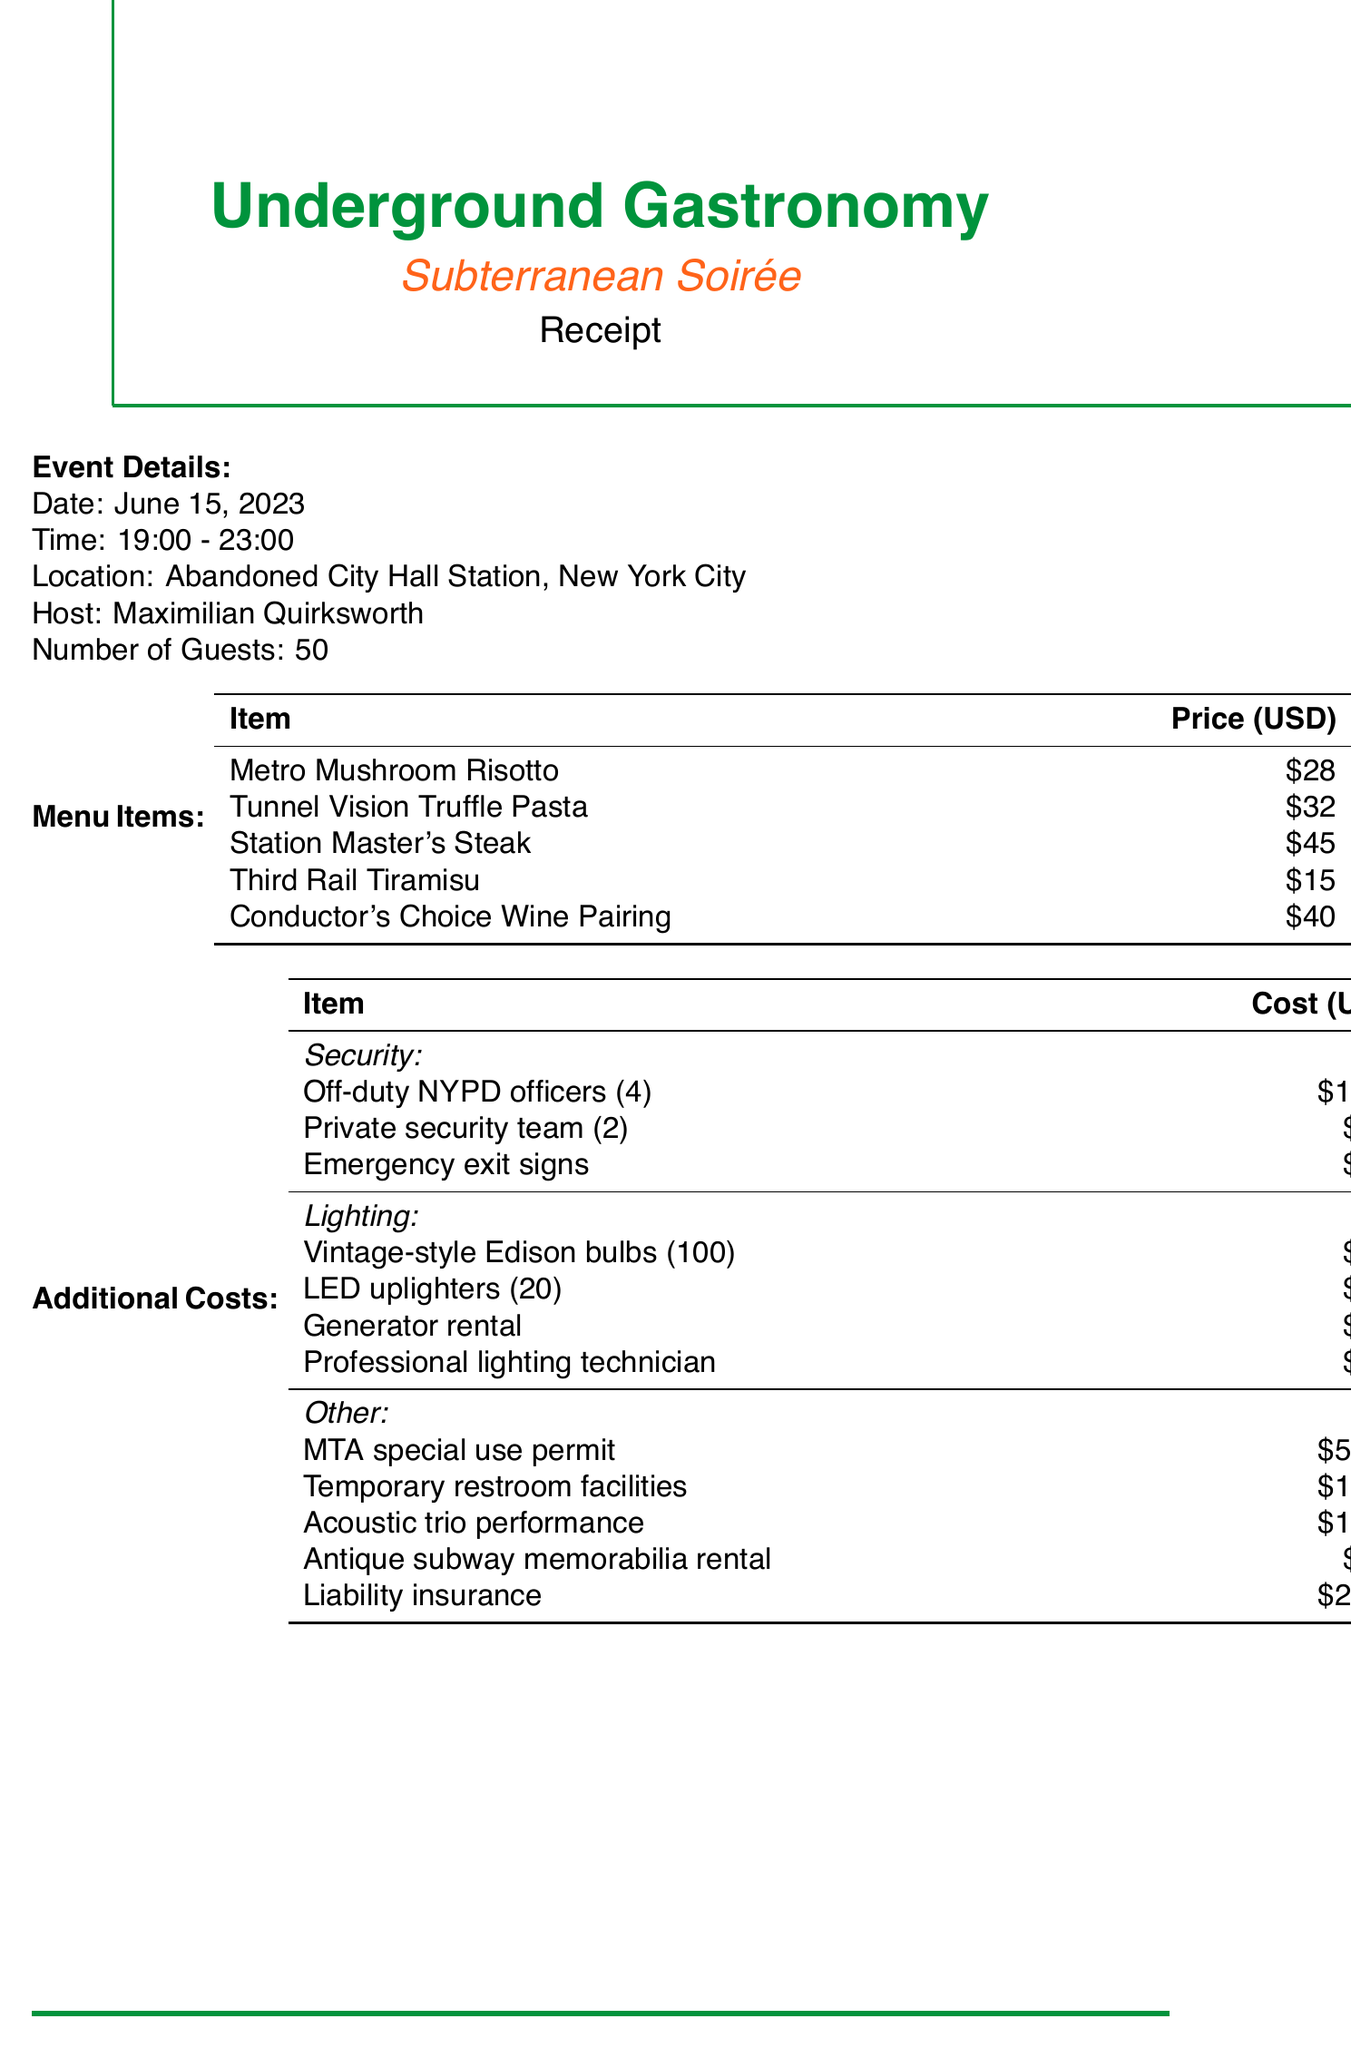What was the date of the event? The document states that the event took place on June 15, 2023.
Answer: June 15, 2023 How many guests were invited? The number of guests is listed in the event details section as 50.
Answer: 50 What was the total cost for security? The total security cost is provided as a distinct figure in the summary section, which amounts to $2,650.
Answer: $2,650 How much did the MTA special use permit cost? The document specifies that the MTA special use permit cost $5,000 under additional costs.
Answer: $5,000 What type of lighting was used? It mentions several items including vintage-style Edison bulbs and LED uplighters as part of the lighting costs.
Answer: Vintage-style Edison bulbs and LED uplighters What was the grand total amount for the event? The grand total is summarized at the end of the document, which is $27,249.08.
Answer: $27,249.08 How much was allocated for the beverage package? The beverage package cost is presented in the menu items section as $40.
Answer: $40 What is the cost of temporary restroom facilities? The document lists the cost of temporary restroom facilities as $1,200 under additional costs.
Answer: $1,200 Who hosted the event? The document identifies the host of the event as Maximilian Quirksworth.
Answer: Maximilian Quirksworth 